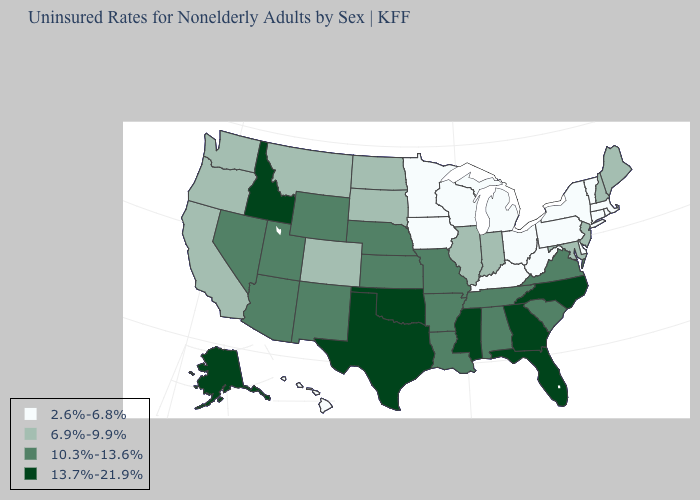Which states have the lowest value in the USA?
Keep it brief. Connecticut, Delaware, Hawaii, Iowa, Kentucky, Massachusetts, Michigan, Minnesota, New York, Ohio, Pennsylvania, Rhode Island, Vermont, West Virginia, Wisconsin. Does Ohio have a lower value than South Dakota?
Be succinct. Yes. What is the value of Alaska?
Keep it brief. 13.7%-21.9%. How many symbols are there in the legend?
Answer briefly. 4. What is the value of Kansas?
Answer briefly. 10.3%-13.6%. What is the lowest value in the USA?
Answer briefly. 2.6%-6.8%. What is the lowest value in the South?
Quick response, please. 2.6%-6.8%. Among the states that border Massachusetts , which have the lowest value?
Answer briefly. Connecticut, New York, Rhode Island, Vermont. Does New Jersey have the highest value in the Northeast?
Concise answer only. Yes. How many symbols are there in the legend?
Write a very short answer. 4. Which states hav the highest value in the West?
Write a very short answer. Alaska, Idaho. Which states hav the highest value in the South?
Give a very brief answer. Florida, Georgia, Mississippi, North Carolina, Oklahoma, Texas. Name the states that have a value in the range 6.9%-9.9%?
Give a very brief answer. California, Colorado, Illinois, Indiana, Maine, Maryland, Montana, New Hampshire, New Jersey, North Dakota, Oregon, South Dakota, Washington. Which states hav the highest value in the West?
Short answer required. Alaska, Idaho. What is the value of Iowa?
Give a very brief answer. 2.6%-6.8%. 